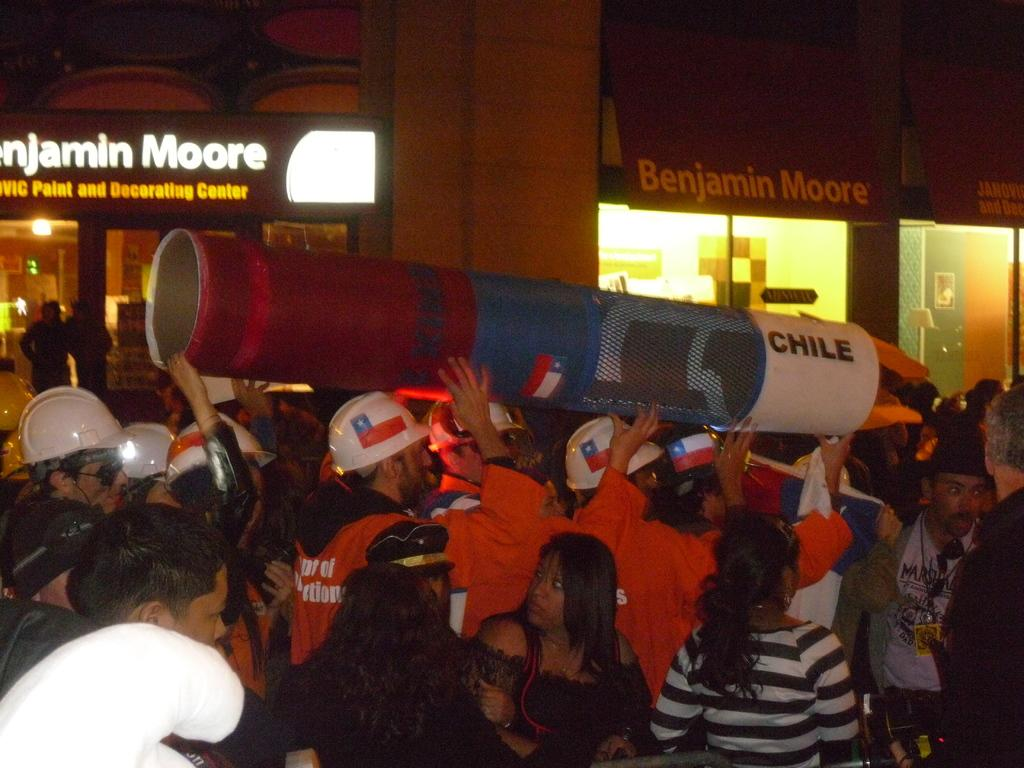What type of people can be seen in the foreground of the picture? There are firefighters in the foreground of the picture. What is located in the foreground of the picture besides the firefighters? There is an object in the foreground of the picture. What can be seen in the background of the picture? There are buildings, light, and people in the background of the picture. What other objects are visible in the background of the picture? There are other objects in the background of the picture. What type of sand can be seen in the picture? There is no sand present in the picture. What type of wine is being served in the background of the picture? There is no wine present in the picture. 